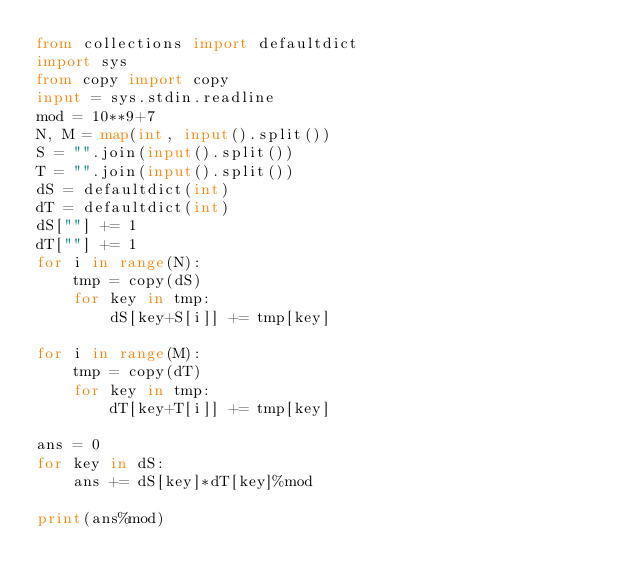<code> <loc_0><loc_0><loc_500><loc_500><_Python_>from collections import defaultdict
import sys
from copy import copy
input = sys.stdin.readline
mod = 10**9+7
N, M = map(int, input().split())
S = "".join(input().split())
T = "".join(input().split())
dS = defaultdict(int)
dT = defaultdict(int)
dS[""] += 1
dT[""] += 1
for i in range(N):
    tmp = copy(dS)
    for key in tmp:
        dS[key+S[i]] += tmp[key]

for i in range(M):
    tmp = copy(dT)
    for key in tmp:
        dT[key+T[i]] += tmp[key]
    
ans = 0
for key in dS:
    ans += dS[key]*dT[key]%mod

print(ans%mod)
</code> 